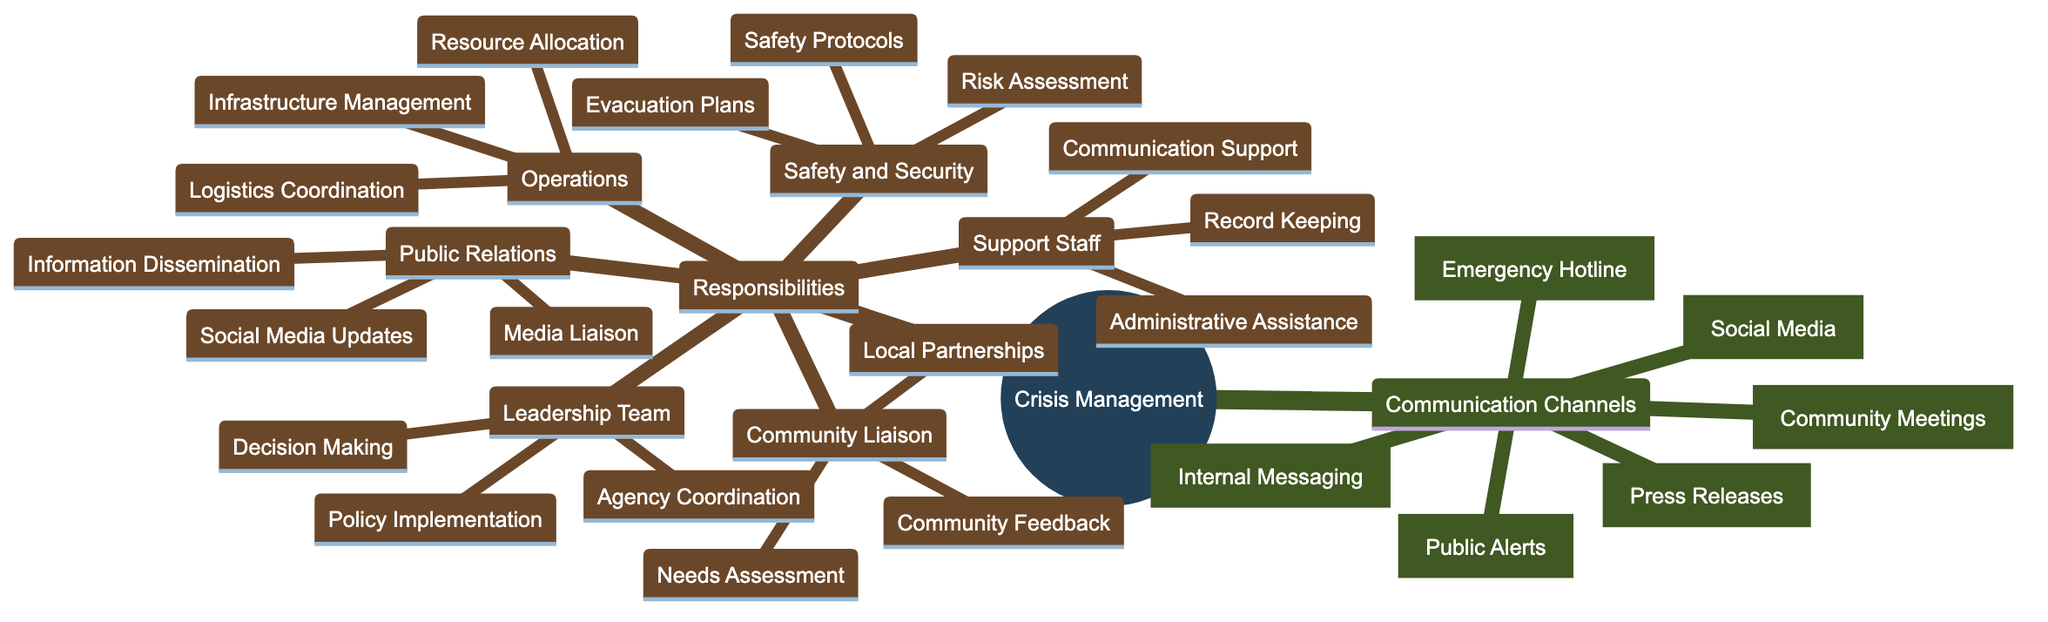What are the communication channels listed? The diagram lists six communication channels under "Communication Channels", which include Emergency Hotline, Social Media, Press Releases, Internal Messaging, Public Alerts, and Community Meetings.
Answer: Emergency Hotline, Social Media, Press Releases, Internal Messaging, Public Alerts, Community Meetings Who is responsible for media liaison? The diagram indicates that the Public Relations team is responsible for media liaison, as outlined in the responsibilities section for that team.
Answer: Public Relations Team How many responsibilities does the Operations team have? By reviewing the Operations section in the Responsibilities part of the diagram, it lists three responsibilities: Resource Allocation, Infrastructure Management, and Logistics Coordination.
Answer: 3 What is the role of the Leadership team in crisis management? The Leadership team is identified in the Responsibilities section, and its role in crisis management involves decision making, coordination with government agencies, and policy implementation.
Answer: Crisis Management Leadership Team Which two teams are responsible for public engagement? The diagram shows that both the Public Relations team and Community Liaison Officers handle aspects of public engagement, where the Public Relations team focuses on media and social media updates, and the Community Liaison Officers work on community feedback and local partnerships.
Answer: Public Relations Team, Community Liaison Officers What is one responsibility of the Safety and Security team? The diagram highlights that the Safety and Security team has responsibilities such as evacuation plans, safety protocols, and risk assessment. Any of these responsibilities can be chosen to answer, but one example is evacuation plans.
Answer: Evacuation Plans How many communication channels are focused on community engagement? The diagram specifically lists the Community Meetings as a channel aimed at local community engagement, although Public Alerts can also serve community needs. However, based on the primary focus, one can conclude that there is one distinct channel dedicated to community engagement.
Answer: 1 What does the support staff do during a crisis? According to the diagram, the responsibilities of the Support Staff include administrative assistance, record keeping, and communication support during a crisis, which outlines their roles clearly.
Answer: Administrative Assistance, Record Keeping, Communication Support 